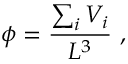<formula> <loc_0><loc_0><loc_500><loc_500>\phi = \frac { \sum _ { i } V _ { i } } { L ^ { 3 } } \ ,</formula> 